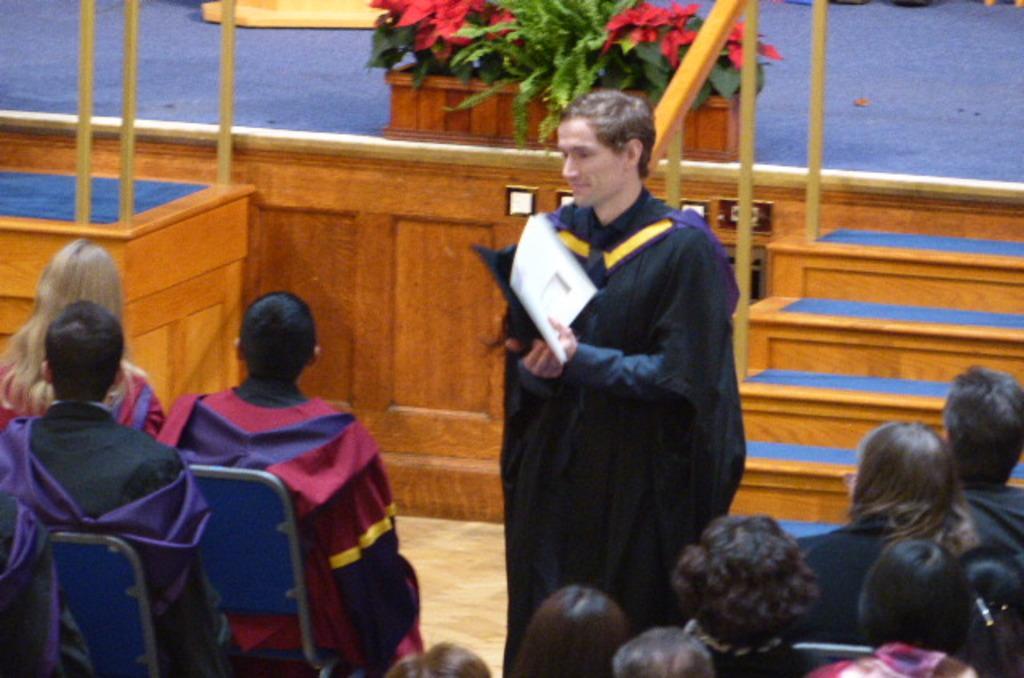In one or two sentences, can you explain what this image depicts? In this image I can see a person standing and holding some objects. There are group of people sitting and in the background there is a stage. Also there are some objects. 